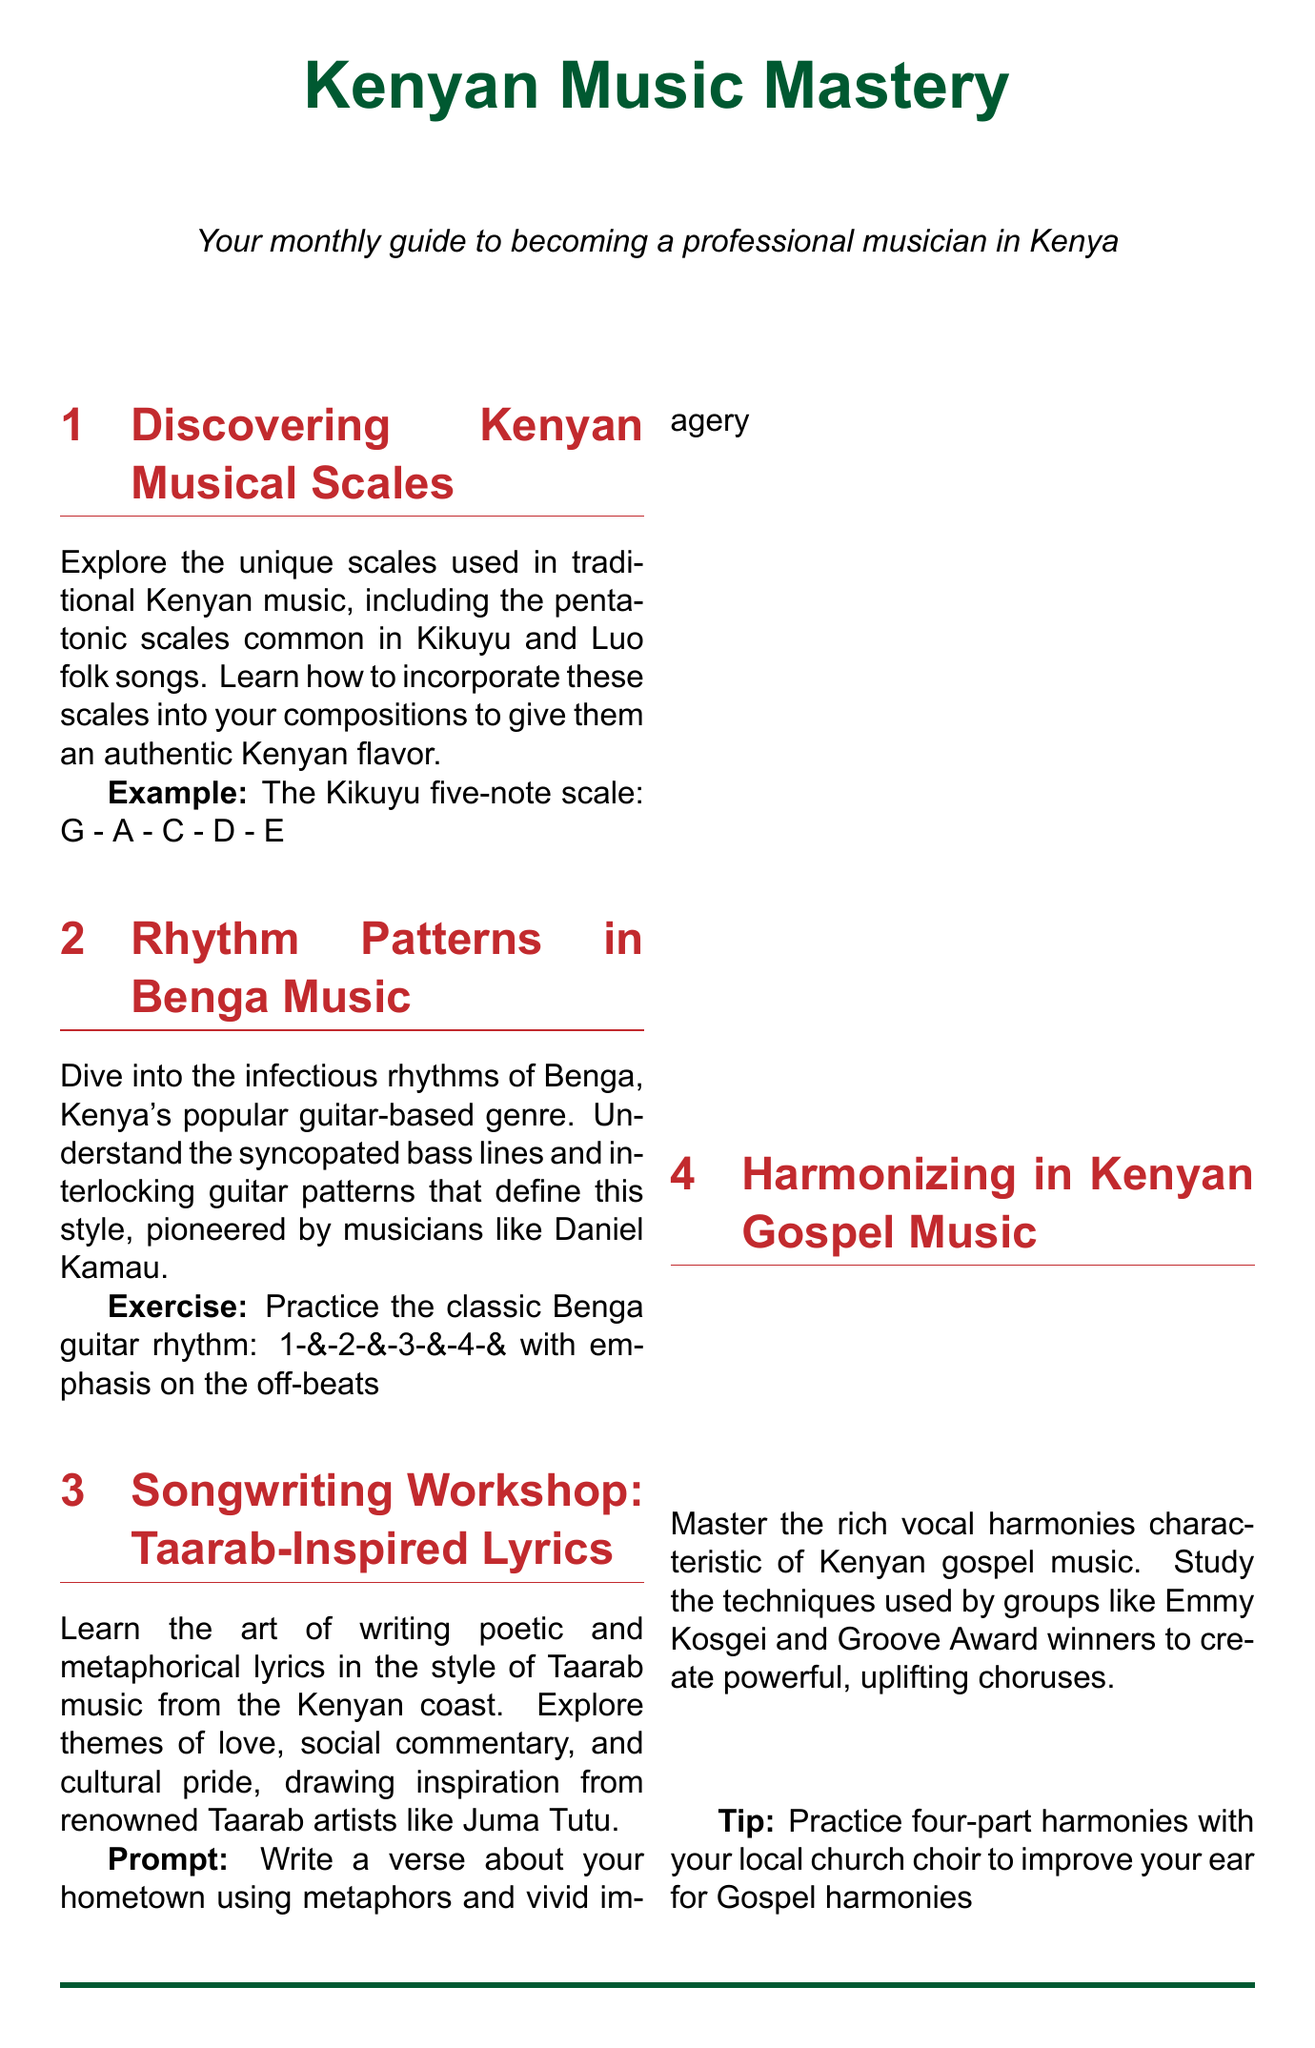What is the title of the newsletter? The title of the newsletter is presented prominently at the beginning of the document.
Answer: Kenyan Music Mastery Who is a notable musician mentioned in Benga Music section? Daniel Kamau is cited as a pioneer of the Benga music style in the document.
Answer: Daniel Kamau What is the example scale provided in the musical scales section? The document includes a specific five-note scale example used in Kikuyu music.
Answer: G - A - C - D - E What genre is the focus of the songwriting workshop? The songwriting workshop section specifically discusses a particular genre of music.
Answer: Taarab How many parts should you practice in the harmonizing section? The document specifies practicing a particular number of vocal parts to improve harmony skills.
Answer: Four What local resource is recommended for recording equipment? The newsletter suggests a specific place for budget-friendly recording equipment options.
Answer: Music Store Nairobi Which group is referenced in the gospel music harmonizing section? A specific artist group known for their gospel harmonies is mentioned in the document.
Answer: Emmy Kosgei What type of copyright entity is mentioned for registration? The document explains a particular organization that musicians should register with for copyright protection.
Answer: Music Copyright Society of Kenya Which song is a case study in the fusion techniques section? A specific hit song is analyzed to illustrate blending traditional and modern styles in the document.
Answer: Kuliko Jana 